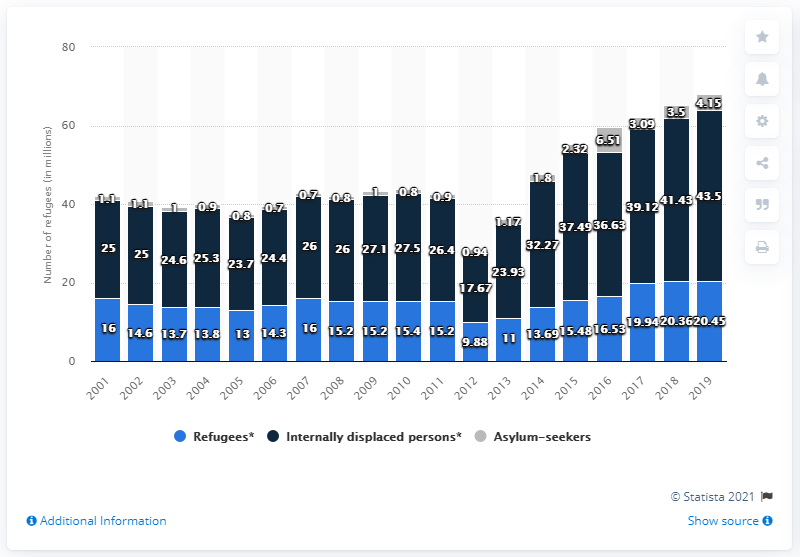List a handful of essential elements in this visual. In 2019, there were approximately 43.5 million people who were internally displaced worldwide. 